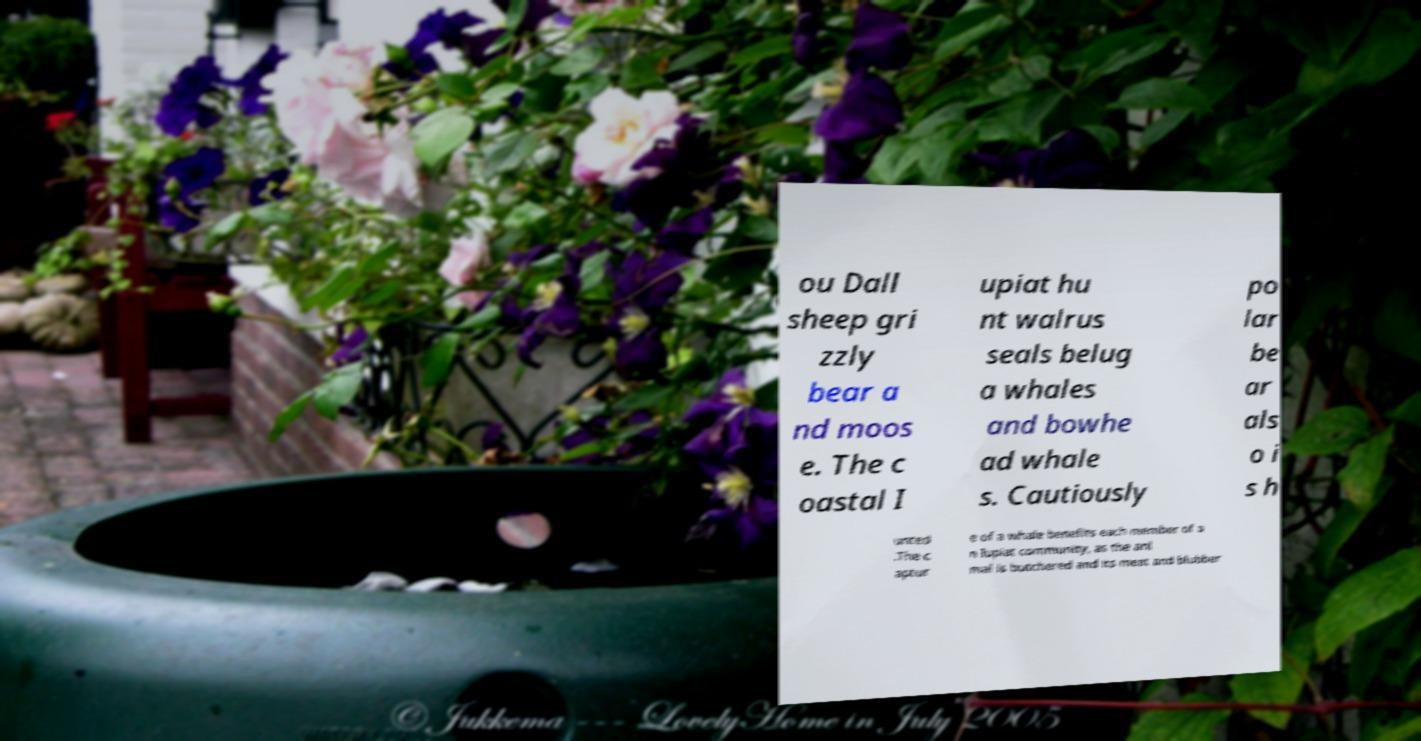For documentation purposes, I need the text within this image transcribed. Could you provide that? ou Dall sheep gri zzly bear a nd moos e. The c oastal I upiat hu nt walrus seals belug a whales and bowhe ad whale s. Cautiously po lar be ar als o i s h unted .The c aptur e of a whale benefits each member of a n Iupiat community, as the ani mal is butchered and its meat and blubber 